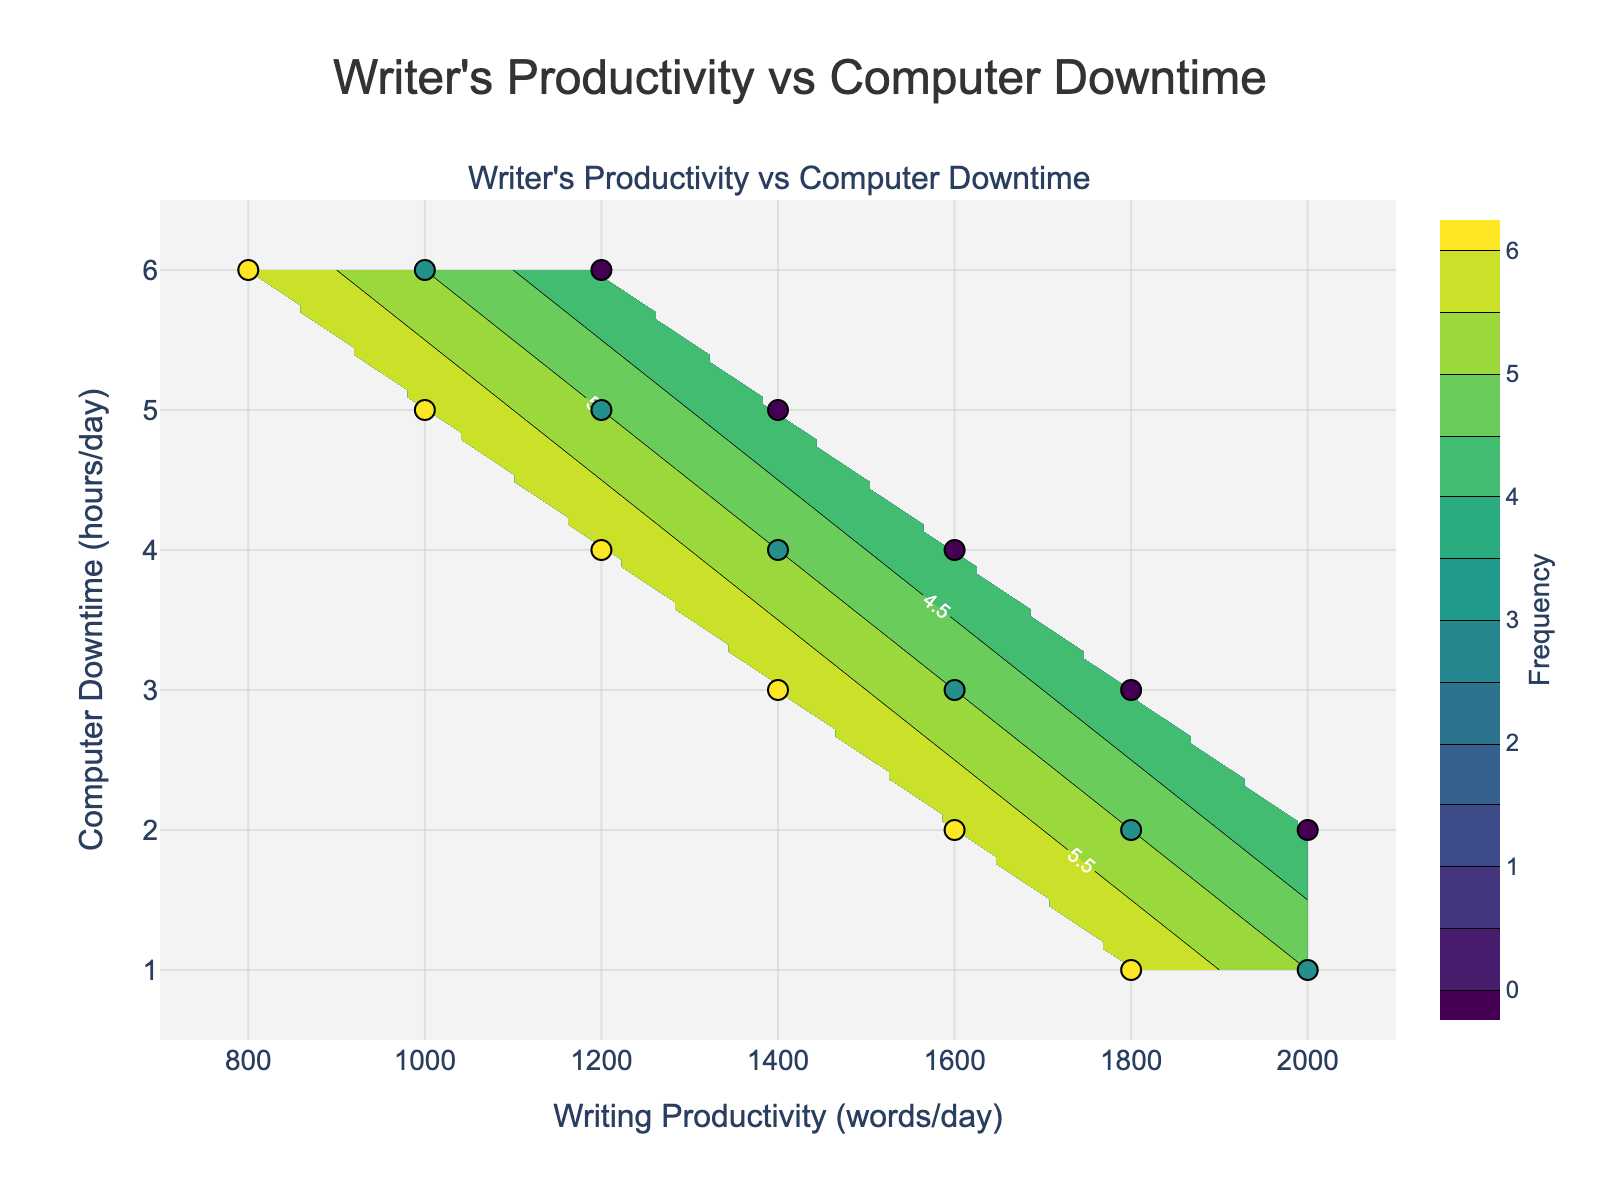What is the title of the figure? The title of the figure is written at the top center of the plot, which reads "Writer's Productivity vs Computer Downtime".
Answer: Writer's Productivity vs Computer Downtime What are the two axes labeled as? The x-axis is labeled as "Writing Productivity (words/day)" and the y-axis is labeled as "Computer Downtime (hours/day)". This information is found along the respective axes of the plot.
Answer: Writing Productivity (words/day); Computer Downtime (hours/day) How many data points are scattered on the plot? By counting the individual markers on the scatter plot overlaid on the contour plot, we can see there are 17 data points.
Answer: 17 What pattern is observed for high frequencies of writing productivity and computer downtime? The highest frequencies (darkest colors on the contour plot) are located at lower values of writing productivity and higher computer downtime, particularly around Writing Productivity of 1000-1200 words/day and Computer Downtime around 5-6 hours/day.
Answer: Lower writing productivity, higher computer downtime Is there greater writing productivity for lower or higher computer downtime? The general trend shows that greater writing productivity is associated with lower computer downtime. The top-left quadrant of the plot, representing higher productivity and lower downtime, tends to have higher contour levels.
Answer: Lower computer downtime What is the frequency range depicted in the contour plot? The contour plot's color bar indicates that the frequency values range from 0 to 6, with color shades representing intervals within this range.
Answer: 0 to 6 Which writing productivity level has the highest frequency with 3 hours of computer downtime? Observing the contour plot, the Writing Productivity level of 1600 words/day has the highest frequency for 3 hours of computer downtime, marked by the darker contour level around this point.
Answer: 1600 words/day What is the frequency at the intersection of 2000 words/day writing productivity and 2 hours/day computer downtime? Referencing the plot, at the intersection of 2000 words/day writing productivity and 2 hours/day computer downtime, the frequency is both indicated by a scatter point and contour levels, showing a frequency of 4.
Answer: 4 Compare the frequencies for 1200 words/day writing productivity and 4 vs. 5 hours/day computer downtime. For 4 hours of computer downtime, the frequency is 6; while for 5 hours of computer downtime, the frequency drops to 5, showing a higher frequency at 4 hours of downtime.
Answer: Higher at 4 hours (6 vs. 5) Which color on the contour plot represents the highest frequency? The color scale on the contour plot shows that the darkest color represents the highest frequency, according to the color legend provided.
Answer: Darkest color (black) 